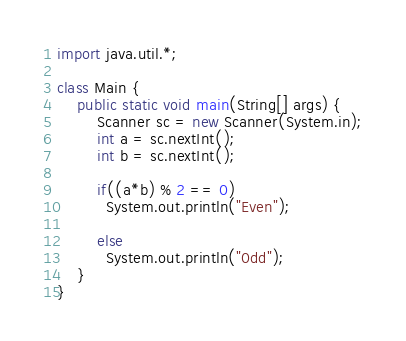<code> <loc_0><loc_0><loc_500><loc_500><_Java_>import java.util.*;

class Main {
    public static void main(String[] args) {
        Scanner sc = new Scanner(System.in);
        int a = sc.nextInt();
        int b = sc.nextInt();
      
        if((a*b) % 2 == 0)
          System.out.println("Even");
      
        else
          System.out.println("0dd");
    }
}
</code> 